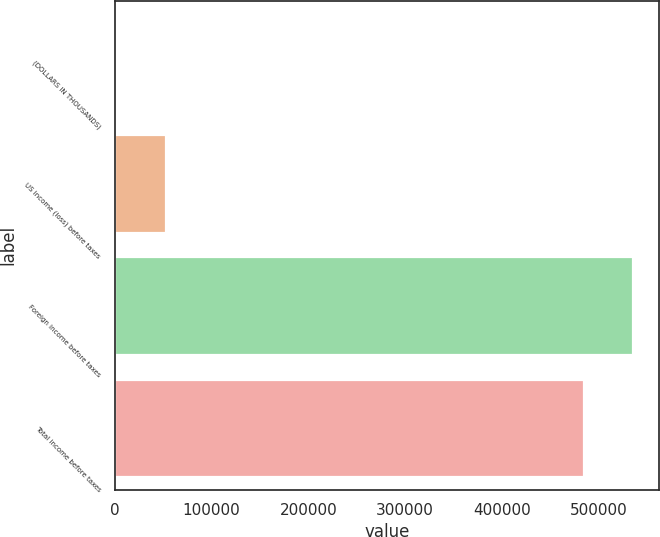<chart> <loc_0><loc_0><loc_500><loc_500><bar_chart><fcel>(DOLLARS IN THOUSANDS)<fcel>US income (loss) before taxes<fcel>Foreign income before taxes<fcel>Total income before taxes<nl><fcel>2013<fcel>52405.4<fcel>535602<fcel>485210<nl></chart> 